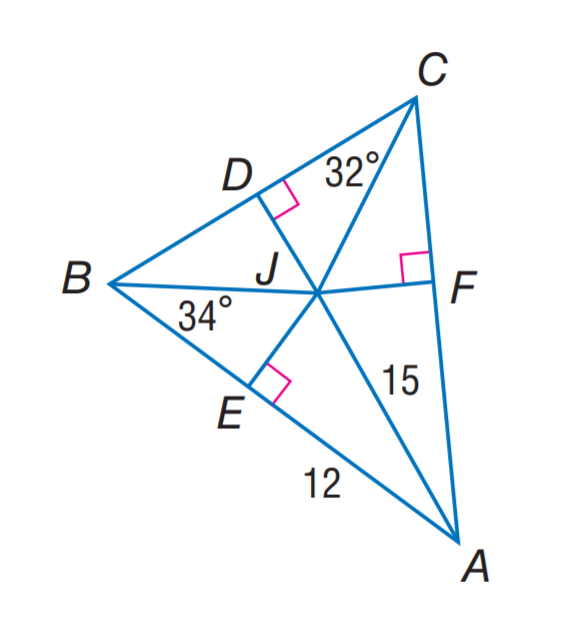Question: J is the incenter of \angle A B C. Find m \angle J A C.
Choices:
A. 15
B. 24
C. 32
D. 34
Answer with the letter. Answer: B Question: J is the incenter of \angle A B C. Find J F.
Choices:
A. 9
B. 12
C. 15
D. 32
Answer with the letter. Answer: A 